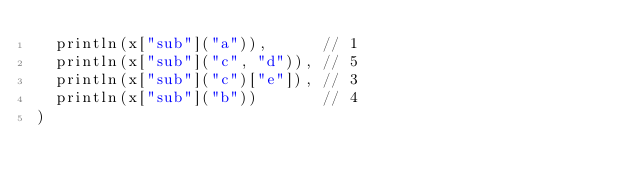Convert code to text. <code><loc_0><loc_0><loc_500><loc_500><_SQL_>  println(x["sub"]("a")),      // 1
  println(x["sub"]("c", "d")), // 5
  println(x["sub"]("c")["e"]), // 3
  println(x["sub"]("b"))       // 4
)    </code> 